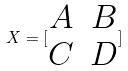<formula> <loc_0><loc_0><loc_500><loc_500>X = [ \begin{matrix} A & B \\ C & D \end{matrix} ]</formula> 